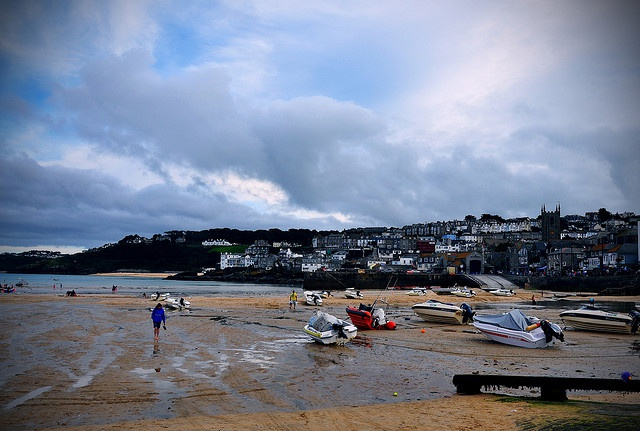Describe the objects in this image and their specific colors. I can see boat in darkblue, gray, black, and darkgray tones, boat in darkblue, black, gray, and darkgray tones, boat in darkblue, gray, darkgray, black, and lavender tones, boat in darkblue, black, maroon, gray, and darkgray tones, and boat in darkblue, black, gray, and lightgray tones in this image. 